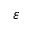<formula> <loc_0><loc_0><loc_500><loc_500>\varepsilon</formula> 